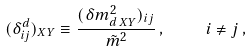<formula> <loc_0><loc_0><loc_500><loc_500>( \delta ^ { d } _ { i j } ) _ { X Y } \equiv \frac { ( \delta m ^ { 2 } _ { d \, X Y } ) _ { i j } } { \tilde { m } ^ { 2 } } \, , \quad i \not = j \, ,</formula> 